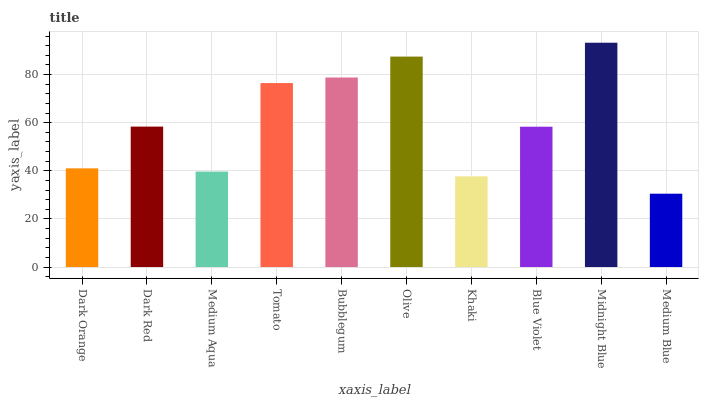Is Dark Red the minimum?
Answer yes or no. No. Is Dark Red the maximum?
Answer yes or no. No. Is Dark Red greater than Dark Orange?
Answer yes or no. Yes. Is Dark Orange less than Dark Red?
Answer yes or no. Yes. Is Dark Orange greater than Dark Red?
Answer yes or no. No. Is Dark Red less than Dark Orange?
Answer yes or no. No. Is Dark Red the high median?
Answer yes or no. Yes. Is Blue Violet the low median?
Answer yes or no. Yes. Is Medium Blue the high median?
Answer yes or no. No. Is Bubblegum the low median?
Answer yes or no. No. 